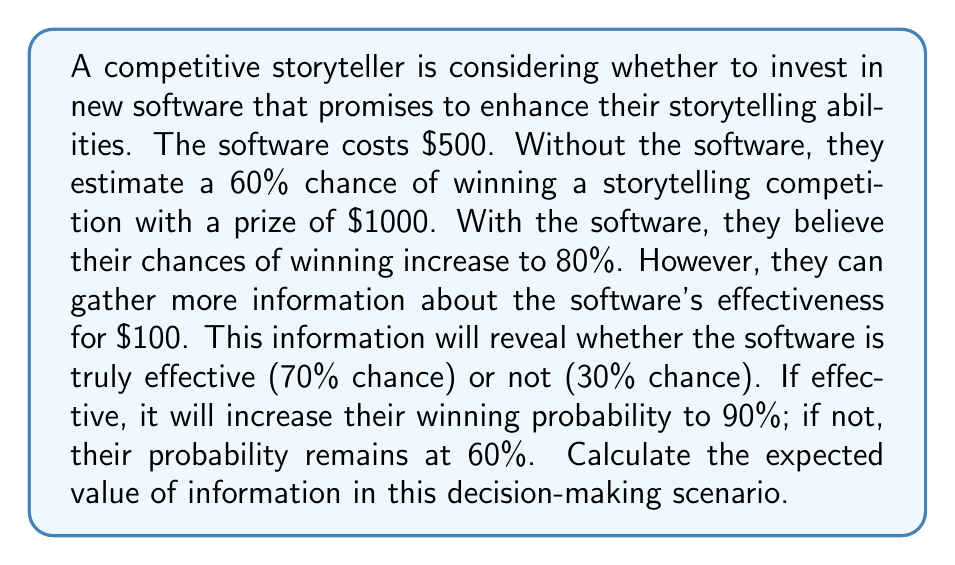Provide a solution to this math problem. Let's approach this step-by-step:

1) First, calculate the expected value without additional information:
   - Without software: $EV_1 = 0.6 \times \$1000 - \$0 = \$600$
   - With software: $EV_2 = 0.8 \times \$1000 - \$500 = \$300$
   The best decision without information is to not buy the software, with $EV = \$600$.

2) Now, calculate the expected value with perfect information:
   - If software is effective (70% chance):
     $EV_e = 0.9 \times \$1000 - \$500 = \$400$
   - If software is not effective (30% chance):
     $EV_n = 0.6 \times \$1000 - \$0 = \$600$ (don't buy)

   $EV_{perfect} = 0.7 \times \$400 + 0.3 \times \$600 = \$460$

3) Calculate the expected value of perfect information (EVPI):
   $EVPI = EV_{perfect} - EV_{without} = \$460 - \$600 = -\$140$

4) However, the information costs $100. The expected value of information (EVI) is:
   $EVI = EVPI - \text{cost of information} = -\$140 - \$100 = -\$240$

The negative EVI indicates that gathering this information is not worthwhile in this scenario.
Answer: $-\$240$ 